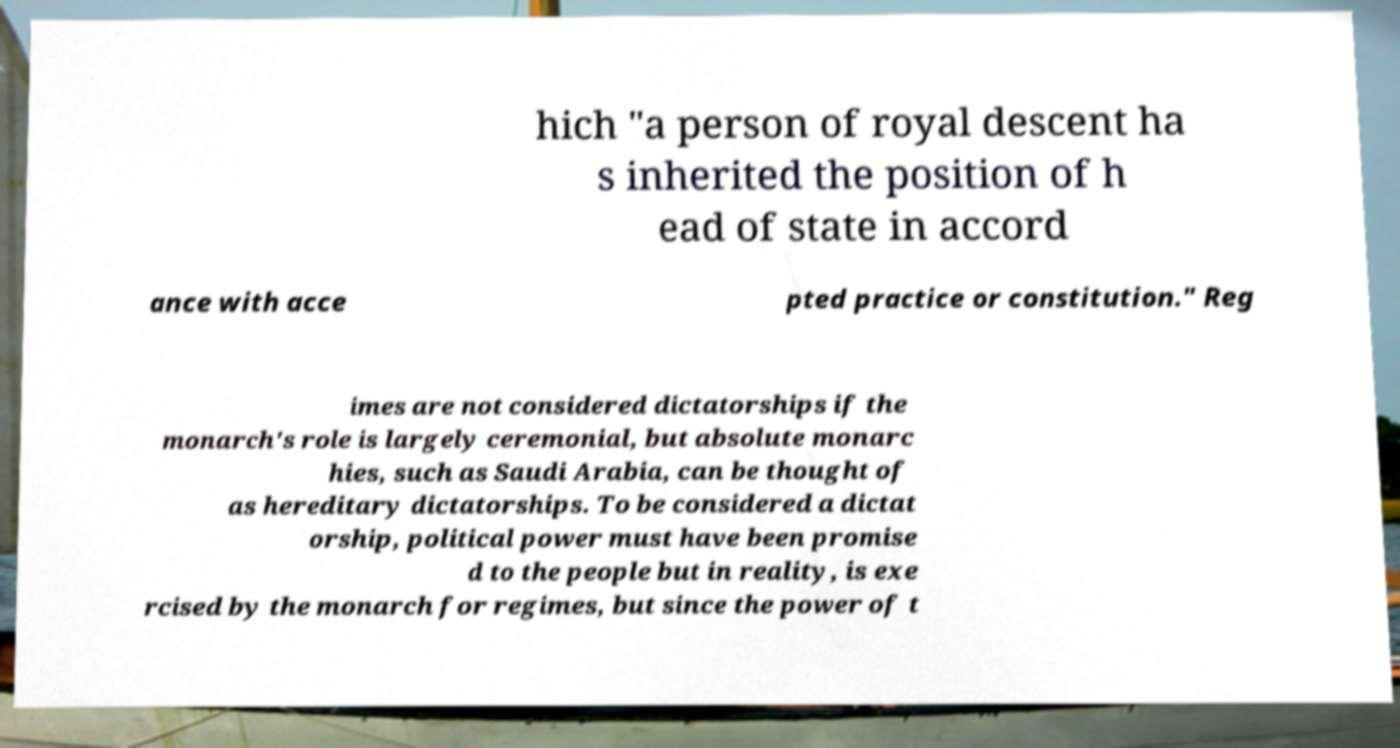Please identify and transcribe the text found in this image. hich "a person of royal descent ha s inherited the position of h ead of state in accord ance with acce pted practice or constitution." Reg imes are not considered dictatorships if the monarch's role is largely ceremonial, but absolute monarc hies, such as Saudi Arabia, can be thought of as hereditary dictatorships. To be considered a dictat orship, political power must have been promise d to the people but in reality, is exe rcised by the monarch for regimes, but since the power of t 